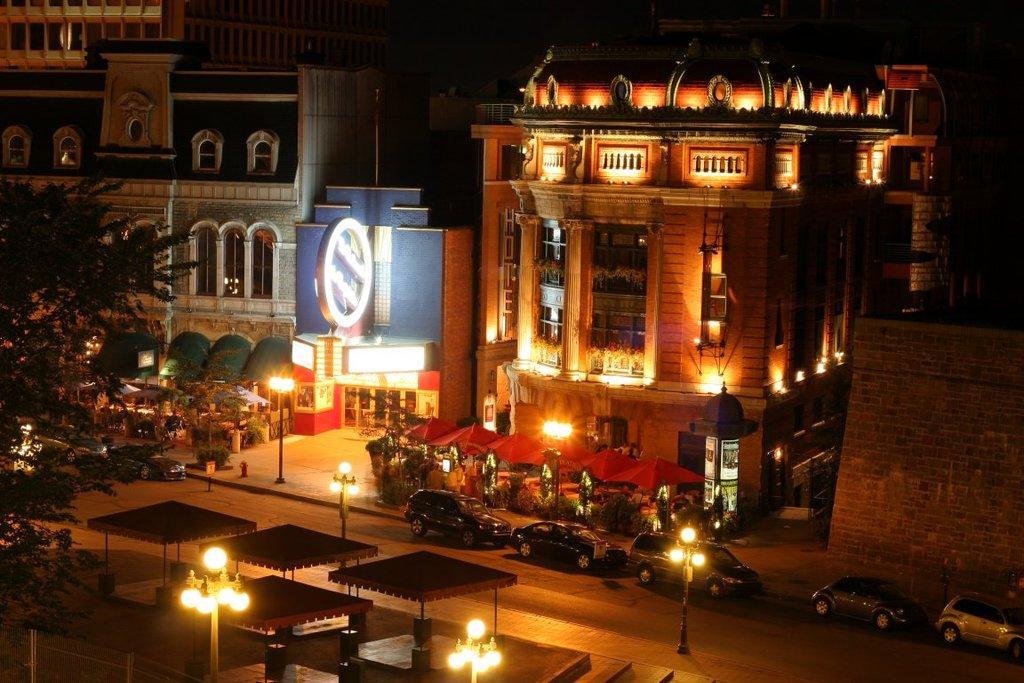Can you describe this image briefly? In the picture there are buildings, street lights, vehicles and in front of the buildings there are stalls. There is a tree on the left side. 